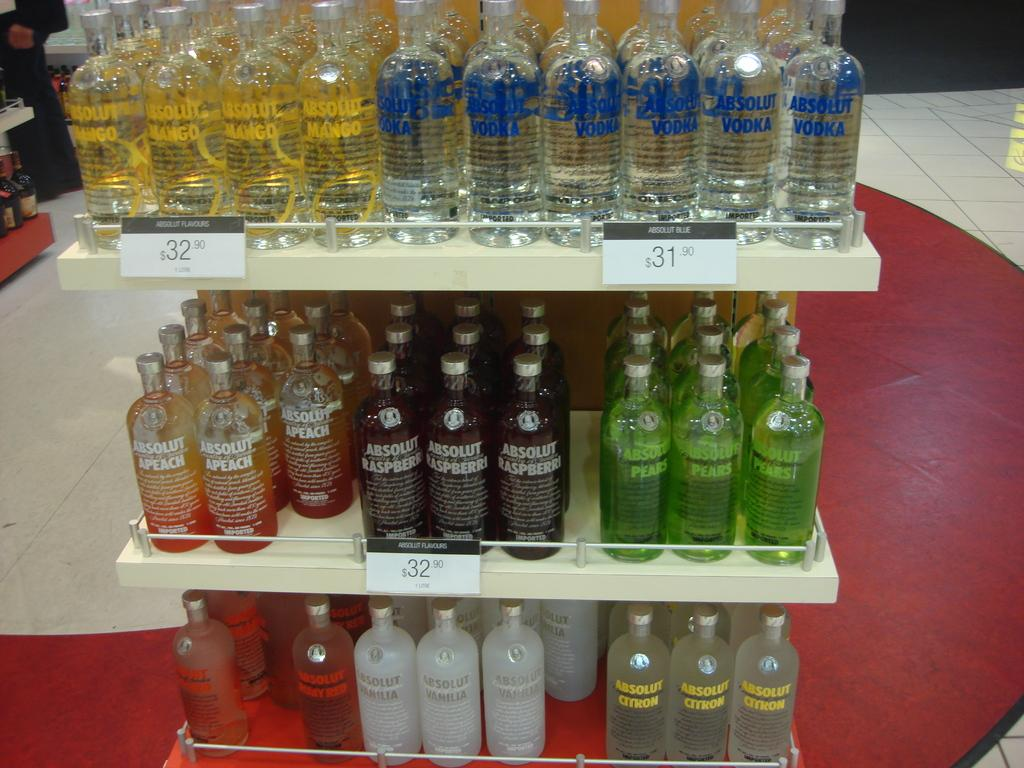What type of bottles are visible in the image? There are vodka bottles in the image. Where are the vodka bottles located? The vodka bottles are on a shelf. What type of farmer is shown working in the image? There is no farmer present in the image; it only features vodka bottles on a shelf. How does the heat affect the vodka bottles in the image? The image does not show any heat or temperature changes affecting the vodka bottles. 